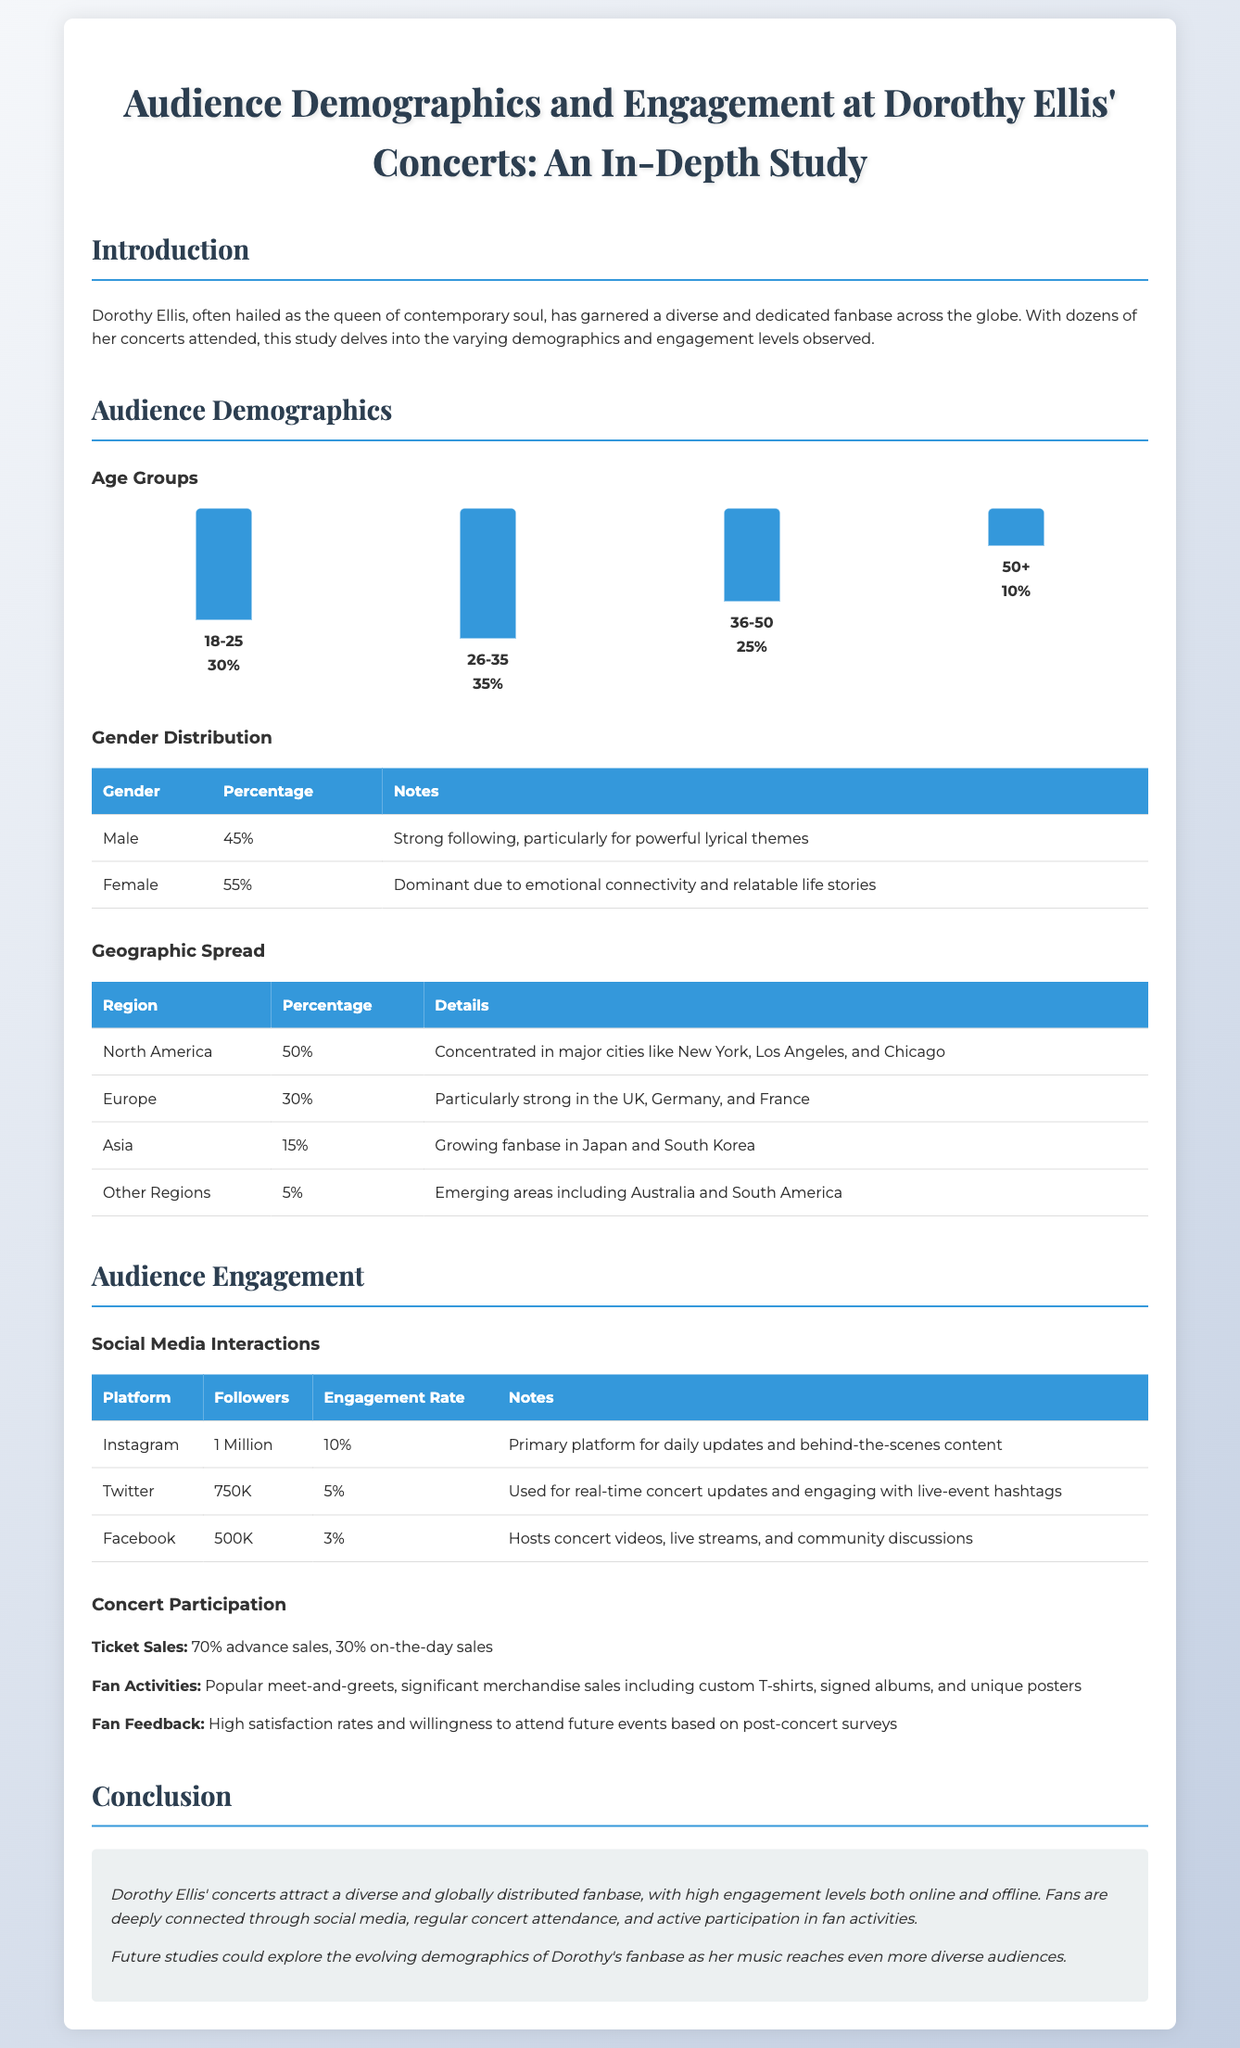what percentage of the audience is aged 26-35? The document states that 35% of the audience falls within the age group of 26-35.
Answer: 35% which gender has a dominant following at the concerts? The document indicates that 55% of the audience is female, highlighting this gender's stronger emotional connectivity with the artist's music.
Answer: Female what is the engagement rate for Dorothy Ellis' Instagram? The engagement rate for Instagram is specified as 10%.
Answer: 10% in which region does North America account for what percentage of the audience? The document shows that North America accounts for 50% of the audience.
Answer: 50% what percentage of ticket sales are made in advance? The document mentions that 70% of ticket sales are made in advance.
Answer: 70% what is the primary platform for daily updates and behind-the-scenes content? The document identifies Instagram as the primary platform for such content.
Answer: Instagram which age group has the lowest representation among concert attendees? The document highlights that the age group 50+ has the lowest representation at 10%.
Answer: 50+ what is the percentage of males in the audience? The document provides the percentage of males as 45%.
Answer: 45% what fans' feedback indicates regarding future attendance at concerts? The document mentions that fans show high satisfaction rates and willingness to attend future events based on feedback.
Answer: High satisfaction rates 